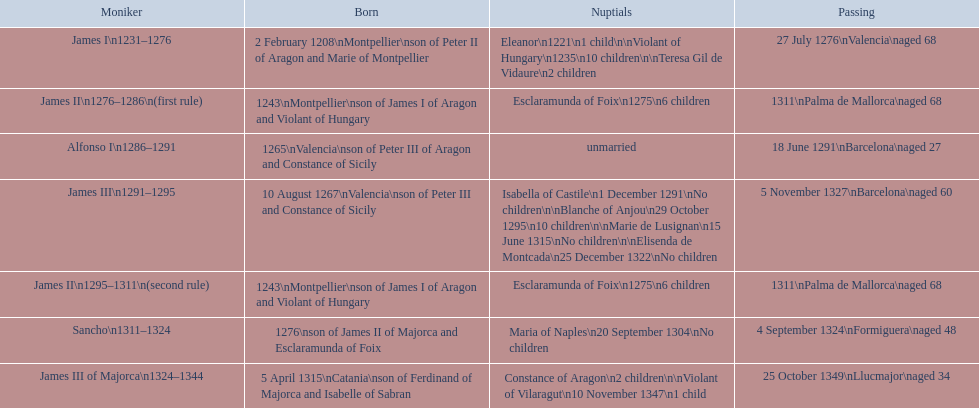How long was james ii in power, including his second rule? 26 years. 